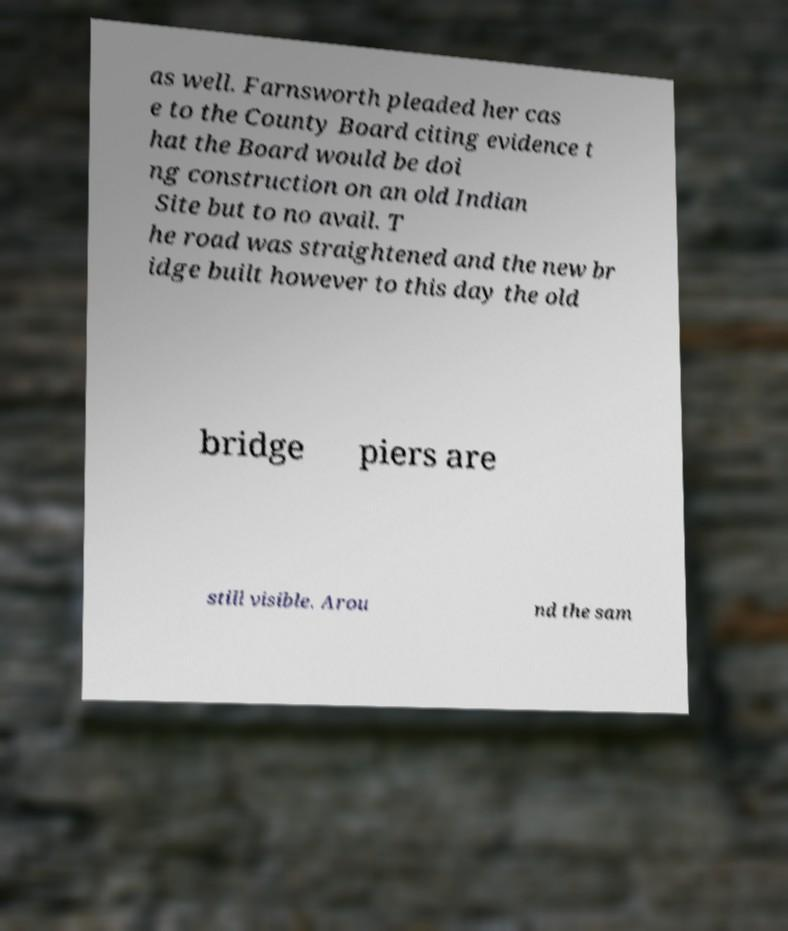For documentation purposes, I need the text within this image transcribed. Could you provide that? as well. Farnsworth pleaded her cas e to the County Board citing evidence t hat the Board would be doi ng construction on an old Indian Site but to no avail. T he road was straightened and the new br idge built however to this day the old bridge piers are still visible. Arou nd the sam 